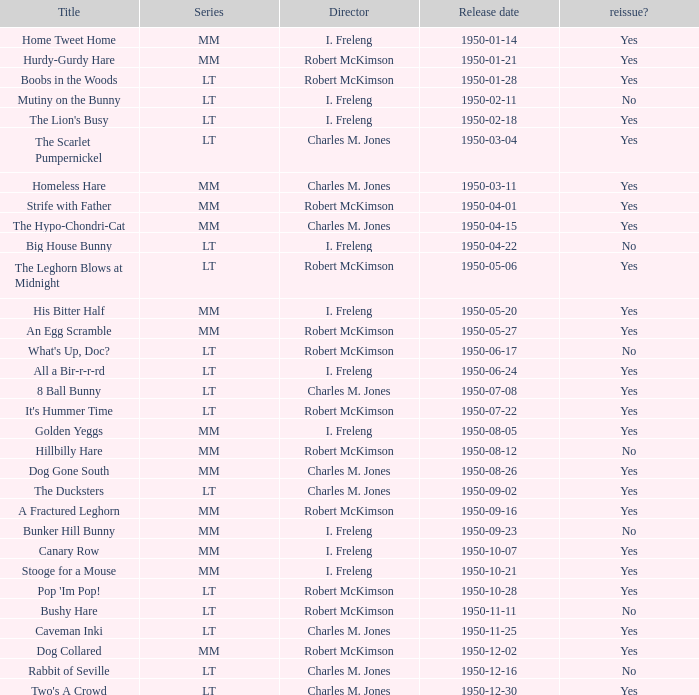Who helmed an egg scramble? Robert McKimson. 